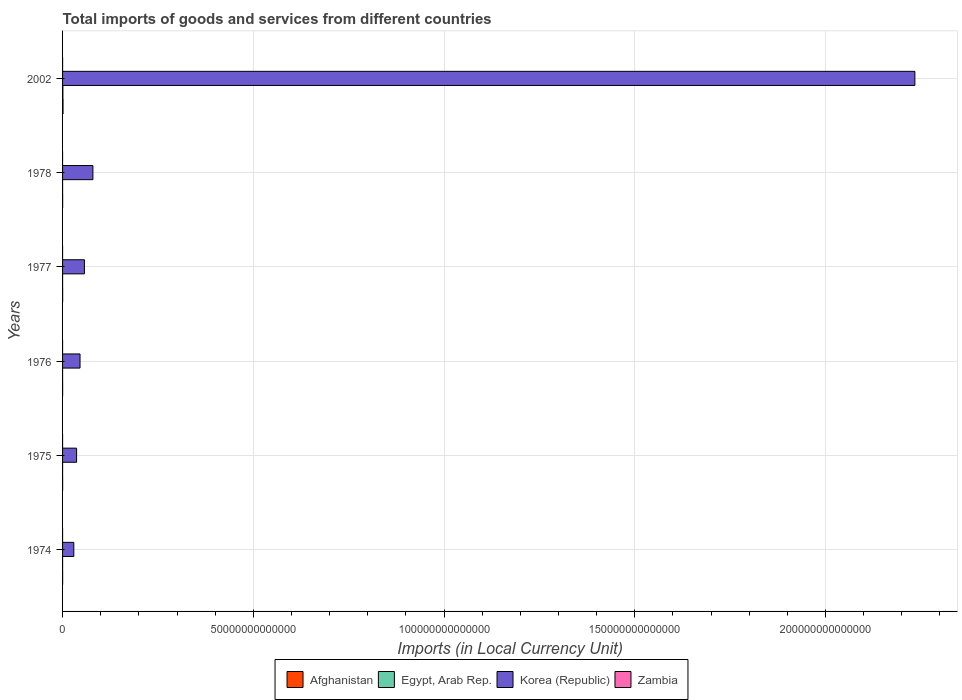How many different coloured bars are there?
Offer a terse response. 4. Are the number of bars per tick equal to the number of legend labels?
Provide a succinct answer. Yes. How many bars are there on the 6th tick from the bottom?
Offer a terse response. 4. What is the label of the 4th group of bars from the top?
Keep it short and to the point. 1976. In how many cases, is the number of bars for a given year not equal to the number of legend labels?
Your answer should be compact. 0. What is the Amount of goods and services imports in Zambia in 1978?
Offer a terse response. 8.31e+05. Across all years, what is the maximum Amount of goods and services imports in Egypt, Arab Rep.?
Provide a succinct answer. 8.59e+1. Across all years, what is the minimum Amount of goods and services imports in Zambia?
Keep it short and to the point. 7.39e+05. In which year was the Amount of goods and services imports in Afghanistan maximum?
Provide a short and direct response. 2002. In which year was the Amount of goods and services imports in Zambia minimum?
Make the answer very short. 1976. What is the total Amount of goods and services imports in Afghanistan in the graph?
Your answer should be compact. 2.08e+11. What is the difference between the Amount of goods and services imports in Korea (Republic) in 1974 and that in 1975?
Offer a terse response. -7.30e+11. What is the difference between the Amount of goods and services imports in Korea (Republic) in 1977 and the Amount of goods and services imports in Egypt, Arab Rep. in 1974?
Offer a very short reply. 5.73e+12. What is the average Amount of goods and services imports in Korea (Republic) per year?
Offer a very short reply. 4.14e+13. In the year 1975, what is the difference between the Amount of goods and services imports in Korea (Republic) and Amount of goods and services imports in Zambia?
Offer a very short reply. 3.68e+12. In how many years, is the Amount of goods and services imports in Zambia greater than 60000000000000 LCU?
Offer a terse response. 0. What is the ratio of the Amount of goods and services imports in Korea (Republic) in 1976 to that in 2002?
Make the answer very short. 0.02. Is the difference between the Amount of goods and services imports in Korea (Republic) in 1977 and 2002 greater than the difference between the Amount of goods and services imports in Zambia in 1977 and 2002?
Offer a very short reply. No. What is the difference between the highest and the second highest Amount of goods and services imports in Egypt, Arab Rep.?
Your answer should be very brief. 8.23e+1. What is the difference between the highest and the lowest Amount of goods and services imports in Egypt, Arab Rep.?
Keep it short and to the point. 8.43e+1. Is it the case that in every year, the sum of the Amount of goods and services imports in Egypt, Arab Rep. and Amount of goods and services imports in Korea (Republic) is greater than the sum of Amount of goods and services imports in Zambia and Amount of goods and services imports in Afghanistan?
Give a very brief answer. Yes. What does the 4th bar from the bottom in 1976 represents?
Give a very brief answer. Zambia. Is it the case that in every year, the sum of the Amount of goods and services imports in Korea (Republic) and Amount of goods and services imports in Egypt, Arab Rep. is greater than the Amount of goods and services imports in Zambia?
Keep it short and to the point. Yes. How many years are there in the graph?
Provide a succinct answer. 6. What is the difference between two consecutive major ticks on the X-axis?
Give a very brief answer. 5.00e+13. Are the values on the major ticks of X-axis written in scientific E-notation?
Provide a succinct answer. No. Where does the legend appear in the graph?
Give a very brief answer. Bottom center. What is the title of the graph?
Make the answer very short. Total imports of goods and services from different countries. What is the label or title of the X-axis?
Make the answer very short. Imports (in Local Currency Unit). What is the Imports (in Local Currency Unit) of Afghanistan in 1974?
Keep it short and to the point. 1.44e+1. What is the Imports (in Local Currency Unit) in Egypt, Arab Rep. in 1974?
Ensure brevity in your answer.  1.62e+09. What is the Imports (in Local Currency Unit) in Korea (Republic) in 1974?
Your answer should be very brief. 2.95e+12. What is the Imports (in Local Currency Unit) of Zambia in 1974?
Provide a short and direct response. 7.66e+05. What is the Imports (in Local Currency Unit) of Afghanistan in 1975?
Ensure brevity in your answer.  1.52e+1. What is the Imports (in Local Currency Unit) in Egypt, Arab Rep. in 1975?
Your answer should be very brief. 2.15e+09. What is the Imports (in Local Currency Unit) in Korea (Republic) in 1975?
Make the answer very short. 3.68e+12. What is the Imports (in Local Currency Unit) in Zambia in 1975?
Provide a short and direct response. 8.84e+05. What is the Imports (in Local Currency Unit) of Afghanistan in 1976?
Provide a succinct answer. 1.71e+1. What is the Imports (in Local Currency Unit) of Egypt, Arab Rep. in 1976?
Your answer should be compact. 2.29e+09. What is the Imports (in Local Currency Unit) in Korea (Republic) in 1976?
Provide a succinct answer. 4.58e+12. What is the Imports (in Local Currency Unit) in Zambia in 1976?
Provide a succinct answer. 7.39e+05. What is the Imports (in Local Currency Unit) of Afghanistan in 1977?
Keep it short and to the point. 1.97e+1. What is the Imports (in Local Currency Unit) of Egypt, Arab Rep. in 1977?
Provide a short and direct response. 2.77e+09. What is the Imports (in Local Currency Unit) in Korea (Republic) in 1977?
Make the answer very short. 5.73e+12. What is the Imports (in Local Currency Unit) of Zambia in 1977?
Keep it short and to the point. 8.33e+05. What is the Imports (in Local Currency Unit) of Afghanistan in 1978?
Your answer should be compact. 2.06e+1. What is the Imports (in Local Currency Unit) of Egypt, Arab Rep. in 1978?
Make the answer very short. 3.63e+09. What is the Imports (in Local Currency Unit) in Korea (Republic) in 1978?
Your answer should be compact. 7.96e+12. What is the Imports (in Local Currency Unit) of Zambia in 1978?
Your answer should be compact. 8.31e+05. What is the Imports (in Local Currency Unit) of Afghanistan in 2002?
Ensure brevity in your answer.  1.21e+11. What is the Imports (in Local Currency Unit) of Egypt, Arab Rep. in 2002?
Ensure brevity in your answer.  8.59e+1. What is the Imports (in Local Currency Unit) in Korea (Republic) in 2002?
Give a very brief answer. 2.23e+14. What is the Imports (in Local Currency Unit) in Zambia in 2002?
Ensure brevity in your answer.  6.97e+09. Across all years, what is the maximum Imports (in Local Currency Unit) of Afghanistan?
Provide a short and direct response. 1.21e+11. Across all years, what is the maximum Imports (in Local Currency Unit) in Egypt, Arab Rep.?
Give a very brief answer. 8.59e+1. Across all years, what is the maximum Imports (in Local Currency Unit) in Korea (Republic)?
Make the answer very short. 2.23e+14. Across all years, what is the maximum Imports (in Local Currency Unit) in Zambia?
Give a very brief answer. 6.97e+09. Across all years, what is the minimum Imports (in Local Currency Unit) of Afghanistan?
Offer a very short reply. 1.44e+1. Across all years, what is the minimum Imports (in Local Currency Unit) in Egypt, Arab Rep.?
Make the answer very short. 1.62e+09. Across all years, what is the minimum Imports (in Local Currency Unit) of Korea (Republic)?
Your answer should be very brief. 2.95e+12. Across all years, what is the minimum Imports (in Local Currency Unit) in Zambia?
Your answer should be very brief. 7.39e+05. What is the total Imports (in Local Currency Unit) in Afghanistan in the graph?
Give a very brief answer. 2.08e+11. What is the total Imports (in Local Currency Unit) of Egypt, Arab Rep. in the graph?
Your answer should be very brief. 9.84e+1. What is the total Imports (in Local Currency Unit) of Korea (Republic) in the graph?
Provide a succinct answer. 2.48e+14. What is the total Imports (in Local Currency Unit) of Zambia in the graph?
Provide a short and direct response. 6.97e+09. What is the difference between the Imports (in Local Currency Unit) in Afghanistan in 1974 and that in 1975?
Offer a very short reply. -8.00e+08. What is the difference between the Imports (in Local Currency Unit) of Egypt, Arab Rep. in 1974 and that in 1975?
Your response must be concise. -5.38e+08. What is the difference between the Imports (in Local Currency Unit) of Korea (Republic) in 1974 and that in 1975?
Give a very brief answer. -7.30e+11. What is the difference between the Imports (in Local Currency Unit) in Zambia in 1974 and that in 1975?
Provide a succinct answer. -1.18e+05. What is the difference between the Imports (in Local Currency Unit) of Afghanistan in 1974 and that in 1976?
Your response must be concise. -2.70e+09. What is the difference between the Imports (in Local Currency Unit) of Egypt, Arab Rep. in 1974 and that in 1976?
Offer a very short reply. -6.71e+08. What is the difference between the Imports (in Local Currency Unit) in Korea (Republic) in 1974 and that in 1976?
Ensure brevity in your answer.  -1.63e+12. What is the difference between the Imports (in Local Currency Unit) of Zambia in 1974 and that in 1976?
Make the answer very short. 2.65e+04. What is the difference between the Imports (in Local Currency Unit) in Afghanistan in 1974 and that in 1977?
Give a very brief answer. -5.30e+09. What is the difference between the Imports (in Local Currency Unit) of Egypt, Arab Rep. in 1974 and that in 1977?
Your answer should be very brief. -1.15e+09. What is the difference between the Imports (in Local Currency Unit) in Korea (Republic) in 1974 and that in 1977?
Offer a terse response. -2.78e+12. What is the difference between the Imports (in Local Currency Unit) of Zambia in 1974 and that in 1977?
Provide a short and direct response. -6.74e+04. What is the difference between the Imports (in Local Currency Unit) in Afghanistan in 1974 and that in 1978?
Your answer should be very brief. -6.20e+09. What is the difference between the Imports (in Local Currency Unit) of Egypt, Arab Rep. in 1974 and that in 1978?
Provide a short and direct response. -2.01e+09. What is the difference between the Imports (in Local Currency Unit) in Korea (Republic) in 1974 and that in 1978?
Offer a terse response. -5.01e+12. What is the difference between the Imports (in Local Currency Unit) of Zambia in 1974 and that in 1978?
Give a very brief answer. -6.54e+04. What is the difference between the Imports (in Local Currency Unit) in Afghanistan in 1974 and that in 2002?
Offer a terse response. -1.07e+11. What is the difference between the Imports (in Local Currency Unit) in Egypt, Arab Rep. in 1974 and that in 2002?
Make the answer very short. -8.43e+1. What is the difference between the Imports (in Local Currency Unit) in Korea (Republic) in 1974 and that in 2002?
Keep it short and to the point. -2.21e+14. What is the difference between the Imports (in Local Currency Unit) of Zambia in 1974 and that in 2002?
Give a very brief answer. -6.97e+09. What is the difference between the Imports (in Local Currency Unit) in Afghanistan in 1975 and that in 1976?
Keep it short and to the point. -1.90e+09. What is the difference between the Imports (in Local Currency Unit) in Egypt, Arab Rep. in 1975 and that in 1976?
Offer a terse response. -1.33e+08. What is the difference between the Imports (in Local Currency Unit) of Korea (Republic) in 1975 and that in 1976?
Provide a succinct answer. -9.01e+11. What is the difference between the Imports (in Local Currency Unit) in Zambia in 1975 and that in 1976?
Offer a terse response. 1.45e+05. What is the difference between the Imports (in Local Currency Unit) in Afghanistan in 1975 and that in 1977?
Provide a succinct answer. -4.50e+09. What is the difference between the Imports (in Local Currency Unit) in Egypt, Arab Rep. in 1975 and that in 1977?
Provide a succinct answer. -6.16e+08. What is the difference between the Imports (in Local Currency Unit) of Korea (Republic) in 1975 and that in 1977?
Offer a terse response. -2.05e+12. What is the difference between the Imports (in Local Currency Unit) of Zambia in 1975 and that in 1977?
Make the answer very short. 5.09e+04. What is the difference between the Imports (in Local Currency Unit) in Afghanistan in 1975 and that in 1978?
Make the answer very short. -5.40e+09. What is the difference between the Imports (in Local Currency Unit) in Egypt, Arab Rep. in 1975 and that in 1978?
Ensure brevity in your answer.  -1.47e+09. What is the difference between the Imports (in Local Currency Unit) in Korea (Republic) in 1975 and that in 1978?
Offer a terse response. -4.28e+12. What is the difference between the Imports (in Local Currency Unit) of Zambia in 1975 and that in 1978?
Offer a very short reply. 5.29e+04. What is the difference between the Imports (in Local Currency Unit) in Afghanistan in 1975 and that in 2002?
Your response must be concise. -1.06e+11. What is the difference between the Imports (in Local Currency Unit) of Egypt, Arab Rep. in 1975 and that in 2002?
Provide a short and direct response. -8.37e+1. What is the difference between the Imports (in Local Currency Unit) in Korea (Republic) in 1975 and that in 2002?
Your answer should be compact. -2.20e+14. What is the difference between the Imports (in Local Currency Unit) of Zambia in 1975 and that in 2002?
Your answer should be very brief. -6.97e+09. What is the difference between the Imports (in Local Currency Unit) in Afghanistan in 1976 and that in 1977?
Offer a very short reply. -2.60e+09. What is the difference between the Imports (in Local Currency Unit) of Egypt, Arab Rep. in 1976 and that in 1977?
Your answer should be very brief. -4.83e+08. What is the difference between the Imports (in Local Currency Unit) in Korea (Republic) in 1976 and that in 1977?
Your answer should be very brief. -1.15e+12. What is the difference between the Imports (in Local Currency Unit) in Zambia in 1976 and that in 1977?
Your answer should be very brief. -9.39e+04. What is the difference between the Imports (in Local Currency Unit) of Afghanistan in 1976 and that in 1978?
Provide a short and direct response. -3.50e+09. What is the difference between the Imports (in Local Currency Unit) in Egypt, Arab Rep. in 1976 and that in 1978?
Ensure brevity in your answer.  -1.34e+09. What is the difference between the Imports (in Local Currency Unit) of Korea (Republic) in 1976 and that in 1978?
Your answer should be very brief. -3.38e+12. What is the difference between the Imports (in Local Currency Unit) of Zambia in 1976 and that in 1978?
Offer a very short reply. -9.19e+04. What is the difference between the Imports (in Local Currency Unit) in Afghanistan in 1976 and that in 2002?
Provide a short and direct response. -1.04e+11. What is the difference between the Imports (in Local Currency Unit) in Egypt, Arab Rep. in 1976 and that in 2002?
Your answer should be compact. -8.36e+1. What is the difference between the Imports (in Local Currency Unit) of Korea (Republic) in 1976 and that in 2002?
Ensure brevity in your answer.  -2.19e+14. What is the difference between the Imports (in Local Currency Unit) of Zambia in 1976 and that in 2002?
Give a very brief answer. -6.97e+09. What is the difference between the Imports (in Local Currency Unit) of Afghanistan in 1977 and that in 1978?
Offer a terse response. -9.00e+08. What is the difference between the Imports (in Local Currency Unit) of Egypt, Arab Rep. in 1977 and that in 1978?
Give a very brief answer. -8.56e+08. What is the difference between the Imports (in Local Currency Unit) in Korea (Republic) in 1977 and that in 1978?
Make the answer very short. -2.23e+12. What is the difference between the Imports (in Local Currency Unit) of Zambia in 1977 and that in 1978?
Give a very brief answer. 2000. What is the difference between the Imports (in Local Currency Unit) in Afghanistan in 1977 and that in 2002?
Provide a short and direct response. -1.01e+11. What is the difference between the Imports (in Local Currency Unit) in Egypt, Arab Rep. in 1977 and that in 2002?
Offer a terse response. -8.31e+1. What is the difference between the Imports (in Local Currency Unit) in Korea (Republic) in 1977 and that in 2002?
Ensure brevity in your answer.  -2.18e+14. What is the difference between the Imports (in Local Currency Unit) in Zambia in 1977 and that in 2002?
Your answer should be very brief. -6.97e+09. What is the difference between the Imports (in Local Currency Unit) in Afghanistan in 1978 and that in 2002?
Make the answer very short. -1.00e+11. What is the difference between the Imports (in Local Currency Unit) in Egypt, Arab Rep. in 1978 and that in 2002?
Your answer should be compact. -8.23e+1. What is the difference between the Imports (in Local Currency Unit) in Korea (Republic) in 1978 and that in 2002?
Your answer should be very brief. -2.15e+14. What is the difference between the Imports (in Local Currency Unit) of Zambia in 1978 and that in 2002?
Provide a short and direct response. -6.97e+09. What is the difference between the Imports (in Local Currency Unit) in Afghanistan in 1974 and the Imports (in Local Currency Unit) in Egypt, Arab Rep. in 1975?
Provide a succinct answer. 1.22e+1. What is the difference between the Imports (in Local Currency Unit) in Afghanistan in 1974 and the Imports (in Local Currency Unit) in Korea (Republic) in 1975?
Your response must be concise. -3.66e+12. What is the difference between the Imports (in Local Currency Unit) in Afghanistan in 1974 and the Imports (in Local Currency Unit) in Zambia in 1975?
Your answer should be compact. 1.44e+1. What is the difference between the Imports (in Local Currency Unit) in Egypt, Arab Rep. in 1974 and the Imports (in Local Currency Unit) in Korea (Republic) in 1975?
Your answer should be very brief. -3.68e+12. What is the difference between the Imports (in Local Currency Unit) in Egypt, Arab Rep. in 1974 and the Imports (in Local Currency Unit) in Zambia in 1975?
Offer a terse response. 1.62e+09. What is the difference between the Imports (in Local Currency Unit) in Korea (Republic) in 1974 and the Imports (in Local Currency Unit) in Zambia in 1975?
Provide a succinct answer. 2.95e+12. What is the difference between the Imports (in Local Currency Unit) of Afghanistan in 1974 and the Imports (in Local Currency Unit) of Egypt, Arab Rep. in 1976?
Make the answer very short. 1.21e+1. What is the difference between the Imports (in Local Currency Unit) in Afghanistan in 1974 and the Imports (in Local Currency Unit) in Korea (Republic) in 1976?
Ensure brevity in your answer.  -4.56e+12. What is the difference between the Imports (in Local Currency Unit) in Afghanistan in 1974 and the Imports (in Local Currency Unit) in Zambia in 1976?
Provide a succinct answer. 1.44e+1. What is the difference between the Imports (in Local Currency Unit) of Egypt, Arab Rep. in 1974 and the Imports (in Local Currency Unit) of Korea (Republic) in 1976?
Your answer should be compact. -4.58e+12. What is the difference between the Imports (in Local Currency Unit) of Egypt, Arab Rep. in 1974 and the Imports (in Local Currency Unit) of Zambia in 1976?
Your response must be concise. 1.62e+09. What is the difference between the Imports (in Local Currency Unit) of Korea (Republic) in 1974 and the Imports (in Local Currency Unit) of Zambia in 1976?
Your answer should be compact. 2.95e+12. What is the difference between the Imports (in Local Currency Unit) in Afghanistan in 1974 and the Imports (in Local Currency Unit) in Egypt, Arab Rep. in 1977?
Keep it short and to the point. 1.16e+1. What is the difference between the Imports (in Local Currency Unit) of Afghanistan in 1974 and the Imports (in Local Currency Unit) of Korea (Republic) in 1977?
Give a very brief answer. -5.72e+12. What is the difference between the Imports (in Local Currency Unit) in Afghanistan in 1974 and the Imports (in Local Currency Unit) in Zambia in 1977?
Your answer should be compact. 1.44e+1. What is the difference between the Imports (in Local Currency Unit) of Egypt, Arab Rep. in 1974 and the Imports (in Local Currency Unit) of Korea (Republic) in 1977?
Give a very brief answer. -5.73e+12. What is the difference between the Imports (in Local Currency Unit) in Egypt, Arab Rep. in 1974 and the Imports (in Local Currency Unit) in Zambia in 1977?
Offer a very short reply. 1.62e+09. What is the difference between the Imports (in Local Currency Unit) in Korea (Republic) in 1974 and the Imports (in Local Currency Unit) in Zambia in 1977?
Make the answer very short. 2.95e+12. What is the difference between the Imports (in Local Currency Unit) of Afghanistan in 1974 and the Imports (in Local Currency Unit) of Egypt, Arab Rep. in 1978?
Ensure brevity in your answer.  1.08e+1. What is the difference between the Imports (in Local Currency Unit) of Afghanistan in 1974 and the Imports (in Local Currency Unit) of Korea (Republic) in 1978?
Provide a succinct answer. -7.94e+12. What is the difference between the Imports (in Local Currency Unit) in Afghanistan in 1974 and the Imports (in Local Currency Unit) in Zambia in 1978?
Offer a terse response. 1.44e+1. What is the difference between the Imports (in Local Currency Unit) in Egypt, Arab Rep. in 1974 and the Imports (in Local Currency Unit) in Korea (Republic) in 1978?
Give a very brief answer. -7.95e+12. What is the difference between the Imports (in Local Currency Unit) in Egypt, Arab Rep. in 1974 and the Imports (in Local Currency Unit) in Zambia in 1978?
Make the answer very short. 1.62e+09. What is the difference between the Imports (in Local Currency Unit) of Korea (Republic) in 1974 and the Imports (in Local Currency Unit) of Zambia in 1978?
Your answer should be compact. 2.95e+12. What is the difference between the Imports (in Local Currency Unit) of Afghanistan in 1974 and the Imports (in Local Currency Unit) of Egypt, Arab Rep. in 2002?
Give a very brief answer. -7.15e+1. What is the difference between the Imports (in Local Currency Unit) in Afghanistan in 1974 and the Imports (in Local Currency Unit) in Korea (Republic) in 2002?
Offer a very short reply. -2.23e+14. What is the difference between the Imports (in Local Currency Unit) in Afghanistan in 1974 and the Imports (in Local Currency Unit) in Zambia in 2002?
Ensure brevity in your answer.  7.43e+09. What is the difference between the Imports (in Local Currency Unit) of Egypt, Arab Rep. in 1974 and the Imports (in Local Currency Unit) of Korea (Republic) in 2002?
Make the answer very short. -2.23e+14. What is the difference between the Imports (in Local Currency Unit) in Egypt, Arab Rep. in 1974 and the Imports (in Local Currency Unit) in Zambia in 2002?
Offer a terse response. -5.35e+09. What is the difference between the Imports (in Local Currency Unit) in Korea (Republic) in 1974 and the Imports (in Local Currency Unit) in Zambia in 2002?
Make the answer very short. 2.94e+12. What is the difference between the Imports (in Local Currency Unit) in Afghanistan in 1975 and the Imports (in Local Currency Unit) in Egypt, Arab Rep. in 1976?
Your answer should be very brief. 1.29e+1. What is the difference between the Imports (in Local Currency Unit) of Afghanistan in 1975 and the Imports (in Local Currency Unit) of Korea (Republic) in 1976?
Offer a very short reply. -4.56e+12. What is the difference between the Imports (in Local Currency Unit) in Afghanistan in 1975 and the Imports (in Local Currency Unit) in Zambia in 1976?
Your response must be concise. 1.52e+1. What is the difference between the Imports (in Local Currency Unit) of Egypt, Arab Rep. in 1975 and the Imports (in Local Currency Unit) of Korea (Republic) in 1976?
Make the answer very short. -4.58e+12. What is the difference between the Imports (in Local Currency Unit) of Egypt, Arab Rep. in 1975 and the Imports (in Local Currency Unit) of Zambia in 1976?
Provide a succinct answer. 2.15e+09. What is the difference between the Imports (in Local Currency Unit) in Korea (Republic) in 1975 and the Imports (in Local Currency Unit) in Zambia in 1976?
Offer a terse response. 3.68e+12. What is the difference between the Imports (in Local Currency Unit) in Afghanistan in 1975 and the Imports (in Local Currency Unit) in Egypt, Arab Rep. in 1977?
Provide a succinct answer. 1.24e+1. What is the difference between the Imports (in Local Currency Unit) in Afghanistan in 1975 and the Imports (in Local Currency Unit) in Korea (Republic) in 1977?
Your answer should be very brief. -5.71e+12. What is the difference between the Imports (in Local Currency Unit) in Afghanistan in 1975 and the Imports (in Local Currency Unit) in Zambia in 1977?
Give a very brief answer. 1.52e+1. What is the difference between the Imports (in Local Currency Unit) in Egypt, Arab Rep. in 1975 and the Imports (in Local Currency Unit) in Korea (Republic) in 1977?
Give a very brief answer. -5.73e+12. What is the difference between the Imports (in Local Currency Unit) of Egypt, Arab Rep. in 1975 and the Imports (in Local Currency Unit) of Zambia in 1977?
Ensure brevity in your answer.  2.15e+09. What is the difference between the Imports (in Local Currency Unit) in Korea (Republic) in 1975 and the Imports (in Local Currency Unit) in Zambia in 1977?
Your response must be concise. 3.68e+12. What is the difference between the Imports (in Local Currency Unit) in Afghanistan in 1975 and the Imports (in Local Currency Unit) in Egypt, Arab Rep. in 1978?
Your response must be concise. 1.16e+1. What is the difference between the Imports (in Local Currency Unit) of Afghanistan in 1975 and the Imports (in Local Currency Unit) of Korea (Republic) in 1978?
Keep it short and to the point. -7.94e+12. What is the difference between the Imports (in Local Currency Unit) of Afghanistan in 1975 and the Imports (in Local Currency Unit) of Zambia in 1978?
Keep it short and to the point. 1.52e+1. What is the difference between the Imports (in Local Currency Unit) in Egypt, Arab Rep. in 1975 and the Imports (in Local Currency Unit) in Korea (Republic) in 1978?
Provide a succinct answer. -7.95e+12. What is the difference between the Imports (in Local Currency Unit) in Egypt, Arab Rep. in 1975 and the Imports (in Local Currency Unit) in Zambia in 1978?
Make the answer very short. 2.15e+09. What is the difference between the Imports (in Local Currency Unit) of Korea (Republic) in 1975 and the Imports (in Local Currency Unit) of Zambia in 1978?
Provide a succinct answer. 3.68e+12. What is the difference between the Imports (in Local Currency Unit) in Afghanistan in 1975 and the Imports (in Local Currency Unit) in Egypt, Arab Rep. in 2002?
Provide a short and direct response. -7.07e+1. What is the difference between the Imports (in Local Currency Unit) of Afghanistan in 1975 and the Imports (in Local Currency Unit) of Korea (Republic) in 2002?
Give a very brief answer. -2.23e+14. What is the difference between the Imports (in Local Currency Unit) in Afghanistan in 1975 and the Imports (in Local Currency Unit) in Zambia in 2002?
Make the answer very short. 8.23e+09. What is the difference between the Imports (in Local Currency Unit) in Egypt, Arab Rep. in 1975 and the Imports (in Local Currency Unit) in Korea (Republic) in 2002?
Your response must be concise. -2.23e+14. What is the difference between the Imports (in Local Currency Unit) in Egypt, Arab Rep. in 1975 and the Imports (in Local Currency Unit) in Zambia in 2002?
Offer a very short reply. -4.82e+09. What is the difference between the Imports (in Local Currency Unit) of Korea (Republic) in 1975 and the Imports (in Local Currency Unit) of Zambia in 2002?
Your answer should be very brief. 3.67e+12. What is the difference between the Imports (in Local Currency Unit) of Afghanistan in 1976 and the Imports (in Local Currency Unit) of Egypt, Arab Rep. in 1977?
Your answer should be compact. 1.43e+1. What is the difference between the Imports (in Local Currency Unit) in Afghanistan in 1976 and the Imports (in Local Currency Unit) in Korea (Republic) in 1977?
Keep it short and to the point. -5.71e+12. What is the difference between the Imports (in Local Currency Unit) in Afghanistan in 1976 and the Imports (in Local Currency Unit) in Zambia in 1977?
Provide a short and direct response. 1.71e+1. What is the difference between the Imports (in Local Currency Unit) of Egypt, Arab Rep. in 1976 and the Imports (in Local Currency Unit) of Korea (Republic) in 1977?
Offer a terse response. -5.73e+12. What is the difference between the Imports (in Local Currency Unit) of Egypt, Arab Rep. in 1976 and the Imports (in Local Currency Unit) of Zambia in 1977?
Ensure brevity in your answer.  2.29e+09. What is the difference between the Imports (in Local Currency Unit) of Korea (Republic) in 1976 and the Imports (in Local Currency Unit) of Zambia in 1977?
Offer a very short reply. 4.58e+12. What is the difference between the Imports (in Local Currency Unit) of Afghanistan in 1976 and the Imports (in Local Currency Unit) of Egypt, Arab Rep. in 1978?
Offer a very short reply. 1.35e+1. What is the difference between the Imports (in Local Currency Unit) of Afghanistan in 1976 and the Imports (in Local Currency Unit) of Korea (Republic) in 1978?
Offer a terse response. -7.94e+12. What is the difference between the Imports (in Local Currency Unit) in Afghanistan in 1976 and the Imports (in Local Currency Unit) in Zambia in 1978?
Provide a succinct answer. 1.71e+1. What is the difference between the Imports (in Local Currency Unit) in Egypt, Arab Rep. in 1976 and the Imports (in Local Currency Unit) in Korea (Republic) in 1978?
Make the answer very short. -7.95e+12. What is the difference between the Imports (in Local Currency Unit) of Egypt, Arab Rep. in 1976 and the Imports (in Local Currency Unit) of Zambia in 1978?
Your answer should be compact. 2.29e+09. What is the difference between the Imports (in Local Currency Unit) in Korea (Republic) in 1976 and the Imports (in Local Currency Unit) in Zambia in 1978?
Offer a very short reply. 4.58e+12. What is the difference between the Imports (in Local Currency Unit) of Afghanistan in 1976 and the Imports (in Local Currency Unit) of Egypt, Arab Rep. in 2002?
Your response must be concise. -6.88e+1. What is the difference between the Imports (in Local Currency Unit) in Afghanistan in 1976 and the Imports (in Local Currency Unit) in Korea (Republic) in 2002?
Keep it short and to the point. -2.23e+14. What is the difference between the Imports (in Local Currency Unit) in Afghanistan in 1976 and the Imports (in Local Currency Unit) in Zambia in 2002?
Offer a terse response. 1.01e+1. What is the difference between the Imports (in Local Currency Unit) of Egypt, Arab Rep. in 1976 and the Imports (in Local Currency Unit) of Korea (Republic) in 2002?
Offer a very short reply. -2.23e+14. What is the difference between the Imports (in Local Currency Unit) in Egypt, Arab Rep. in 1976 and the Imports (in Local Currency Unit) in Zambia in 2002?
Your answer should be very brief. -4.68e+09. What is the difference between the Imports (in Local Currency Unit) in Korea (Republic) in 1976 and the Imports (in Local Currency Unit) in Zambia in 2002?
Keep it short and to the point. 4.57e+12. What is the difference between the Imports (in Local Currency Unit) in Afghanistan in 1977 and the Imports (in Local Currency Unit) in Egypt, Arab Rep. in 1978?
Keep it short and to the point. 1.61e+1. What is the difference between the Imports (in Local Currency Unit) of Afghanistan in 1977 and the Imports (in Local Currency Unit) of Korea (Republic) in 1978?
Offer a very short reply. -7.94e+12. What is the difference between the Imports (in Local Currency Unit) of Afghanistan in 1977 and the Imports (in Local Currency Unit) of Zambia in 1978?
Offer a terse response. 1.97e+1. What is the difference between the Imports (in Local Currency Unit) of Egypt, Arab Rep. in 1977 and the Imports (in Local Currency Unit) of Korea (Republic) in 1978?
Offer a terse response. -7.95e+12. What is the difference between the Imports (in Local Currency Unit) of Egypt, Arab Rep. in 1977 and the Imports (in Local Currency Unit) of Zambia in 1978?
Provide a short and direct response. 2.77e+09. What is the difference between the Imports (in Local Currency Unit) in Korea (Republic) in 1977 and the Imports (in Local Currency Unit) in Zambia in 1978?
Make the answer very short. 5.73e+12. What is the difference between the Imports (in Local Currency Unit) of Afghanistan in 1977 and the Imports (in Local Currency Unit) of Egypt, Arab Rep. in 2002?
Give a very brief answer. -6.62e+1. What is the difference between the Imports (in Local Currency Unit) of Afghanistan in 1977 and the Imports (in Local Currency Unit) of Korea (Republic) in 2002?
Give a very brief answer. -2.23e+14. What is the difference between the Imports (in Local Currency Unit) of Afghanistan in 1977 and the Imports (in Local Currency Unit) of Zambia in 2002?
Provide a succinct answer. 1.27e+1. What is the difference between the Imports (in Local Currency Unit) in Egypt, Arab Rep. in 1977 and the Imports (in Local Currency Unit) in Korea (Republic) in 2002?
Offer a very short reply. -2.23e+14. What is the difference between the Imports (in Local Currency Unit) in Egypt, Arab Rep. in 1977 and the Imports (in Local Currency Unit) in Zambia in 2002?
Keep it short and to the point. -4.20e+09. What is the difference between the Imports (in Local Currency Unit) in Korea (Republic) in 1977 and the Imports (in Local Currency Unit) in Zambia in 2002?
Offer a terse response. 5.72e+12. What is the difference between the Imports (in Local Currency Unit) of Afghanistan in 1978 and the Imports (in Local Currency Unit) of Egypt, Arab Rep. in 2002?
Ensure brevity in your answer.  -6.53e+1. What is the difference between the Imports (in Local Currency Unit) in Afghanistan in 1978 and the Imports (in Local Currency Unit) in Korea (Republic) in 2002?
Give a very brief answer. -2.23e+14. What is the difference between the Imports (in Local Currency Unit) of Afghanistan in 1978 and the Imports (in Local Currency Unit) of Zambia in 2002?
Provide a short and direct response. 1.36e+1. What is the difference between the Imports (in Local Currency Unit) in Egypt, Arab Rep. in 1978 and the Imports (in Local Currency Unit) in Korea (Republic) in 2002?
Keep it short and to the point. -2.23e+14. What is the difference between the Imports (in Local Currency Unit) in Egypt, Arab Rep. in 1978 and the Imports (in Local Currency Unit) in Zambia in 2002?
Provide a short and direct response. -3.34e+09. What is the difference between the Imports (in Local Currency Unit) in Korea (Republic) in 1978 and the Imports (in Local Currency Unit) in Zambia in 2002?
Your answer should be compact. 7.95e+12. What is the average Imports (in Local Currency Unit) of Afghanistan per year?
Offer a very short reply. 3.47e+1. What is the average Imports (in Local Currency Unit) in Egypt, Arab Rep. per year?
Give a very brief answer. 1.64e+1. What is the average Imports (in Local Currency Unit) of Korea (Republic) per year?
Offer a very short reply. 4.14e+13. What is the average Imports (in Local Currency Unit) in Zambia per year?
Ensure brevity in your answer.  1.16e+09. In the year 1974, what is the difference between the Imports (in Local Currency Unit) in Afghanistan and Imports (in Local Currency Unit) in Egypt, Arab Rep.?
Give a very brief answer. 1.28e+1. In the year 1974, what is the difference between the Imports (in Local Currency Unit) in Afghanistan and Imports (in Local Currency Unit) in Korea (Republic)?
Provide a short and direct response. -2.93e+12. In the year 1974, what is the difference between the Imports (in Local Currency Unit) in Afghanistan and Imports (in Local Currency Unit) in Zambia?
Keep it short and to the point. 1.44e+1. In the year 1974, what is the difference between the Imports (in Local Currency Unit) in Egypt, Arab Rep. and Imports (in Local Currency Unit) in Korea (Republic)?
Give a very brief answer. -2.95e+12. In the year 1974, what is the difference between the Imports (in Local Currency Unit) in Egypt, Arab Rep. and Imports (in Local Currency Unit) in Zambia?
Ensure brevity in your answer.  1.62e+09. In the year 1974, what is the difference between the Imports (in Local Currency Unit) in Korea (Republic) and Imports (in Local Currency Unit) in Zambia?
Ensure brevity in your answer.  2.95e+12. In the year 1975, what is the difference between the Imports (in Local Currency Unit) of Afghanistan and Imports (in Local Currency Unit) of Egypt, Arab Rep.?
Your answer should be compact. 1.30e+1. In the year 1975, what is the difference between the Imports (in Local Currency Unit) of Afghanistan and Imports (in Local Currency Unit) of Korea (Republic)?
Offer a very short reply. -3.66e+12. In the year 1975, what is the difference between the Imports (in Local Currency Unit) in Afghanistan and Imports (in Local Currency Unit) in Zambia?
Offer a very short reply. 1.52e+1. In the year 1975, what is the difference between the Imports (in Local Currency Unit) of Egypt, Arab Rep. and Imports (in Local Currency Unit) of Korea (Republic)?
Keep it short and to the point. -3.68e+12. In the year 1975, what is the difference between the Imports (in Local Currency Unit) in Egypt, Arab Rep. and Imports (in Local Currency Unit) in Zambia?
Give a very brief answer. 2.15e+09. In the year 1975, what is the difference between the Imports (in Local Currency Unit) of Korea (Republic) and Imports (in Local Currency Unit) of Zambia?
Offer a very short reply. 3.68e+12. In the year 1976, what is the difference between the Imports (in Local Currency Unit) in Afghanistan and Imports (in Local Currency Unit) in Egypt, Arab Rep.?
Your response must be concise. 1.48e+1. In the year 1976, what is the difference between the Imports (in Local Currency Unit) of Afghanistan and Imports (in Local Currency Unit) of Korea (Republic)?
Your answer should be very brief. -4.56e+12. In the year 1976, what is the difference between the Imports (in Local Currency Unit) in Afghanistan and Imports (in Local Currency Unit) in Zambia?
Give a very brief answer. 1.71e+1. In the year 1976, what is the difference between the Imports (in Local Currency Unit) of Egypt, Arab Rep. and Imports (in Local Currency Unit) of Korea (Republic)?
Offer a very short reply. -4.58e+12. In the year 1976, what is the difference between the Imports (in Local Currency Unit) in Egypt, Arab Rep. and Imports (in Local Currency Unit) in Zambia?
Ensure brevity in your answer.  2.29e+09. In the year 1976, what is the difference between the Imports (in Local Currency Unit) of Korea (Republic) and Imports (in Local Currency Unit) of Zambia?
Make the answer very short. 4.58e+12. In the year 1977, what is the difference between the Imports (in Local Currency Unit) of Afghanistan and Imports (in Local Currency Unit) of Egypt, Arab Rep.?
Offer a very short reply. 1.69e+1. In the year 1977, what is the difference between the Imports (in Local Currency Unit) in Afghanistan and Imports (in Local Currency Unit) in Korea (Republic)?
Your answer should be compact. -5.71e+12. In the year 1977, what is the difference between the Imports (in Local Currency Unit) of Afghanistan and Imports (in Local Currency Unit) of Zambia?
Offer a terse response. 1.97e+1. In the year 1977, what is the difference between the Imports (in Local Currency Unit) in Egypt, Arab Rep. and Imports (in Local Currency Unit) in Korea (Republic)?
Offer a terse response. -5.73e+12. In the year 1977, what is the difference between the Imports (in Local Currency Unit) of Egypt, Arab Rep. and Imports (in Local Currency Unit) of Zambia?
Offer a terse response. 2.77e+09. In the year 1977, what is the difference between the Imports (in Local Currency Unit) in Korea (Republic) and Imports (in Local Currency Unit) in Zambia?
Your answer should be very brief. 5.73e+12. In the year 1978, what is the difference between the Imports (in Local Currency Unit) in Afghanistan and Imports (in Local Currency Unit) in Egypt, Arab Rep.?
Provide a succinct answer. 1.70e+1. In the year 1978, what is the difference between the Imports (in Local Currency Unit) of Afghanistan and Imports (in Local Currency Unit) of Korea (Republic)?
Your response must be concise. -7.94e+12. In the year 1978, what is the difference between the Imports (in Local Currency Unit) of Afghanistan and Imports (in Local Currency Unit) of Zambia?
Make the answer very short. 2.06e+1. In the year 1978, what is the difference between the Imports (in Local Currency Unit) in Egypt, Arab Rep. and Imports (in Local Currency Unit) in Korea (Republic)?
Your answer should be very brief. -7.95e+12. In the year 1978, what is the difference between the Imports (in Local Currency Unit) of Egypt, Arab Rep. and Imports (in Local Currency Unit) of Zambia?
Keep it short and to the point. 3.63e+09. In the year 1978, what is the difference between the Imports (in Local Currency Unit) of Korea (Republic) and Imports (in Local Currency Unit) of Zambia?
Your answer should be compact. 7.96e+12. In the year 2002, what is the difference between the Imports (in Local Currency Unit) in Afghanistan and Imports (in Local Currency Unit) in Egypt, Arab Rep.?
Provide a succinct answer. 3.52e+1. In the year 2002, what is the difference between the Imports (in Local Currency Unit) of Afghanistan and Imports (in Local Currency Unit) of Korea (Republic)?
Offer a terse response. -2.23e+14. In the year 2002, what is the difference between the Imports (in Local Currency Unit) in Afghanistan and Imports (in Local Currency Unit) in Zambia?
Your answer should be compact. 1.14e+11. In the year 2002, what is the difference between the Imports (in Local Currency Unit) in Egypt, Arab Rep. and Imports (in Local Currency Unit) in Korea (Republic)?
Ensure brevity in your answer.  -2.23e+14. In the year 2002, what is the difference between the Imports (in Local Currency Unit) of Egypt, Arab Rep. and Imports (in Local Currency Unit) of Zambia?
Offer a terse response. 7.89e+1. In the year 2002, what is the difference between the Imports (in Local Currency Unit) in Korea (Republic) and Imports (in Local Currency Unit) in Zambia?
Your answer should be compact. 2.23e+14. What is the ratio of the Imports (in Local Currency Unit) of Egypt, Arab Rep. in 1974 to that in 1975?
Offer a terse response. 0.75. What is the ratio of the Imports (in Local Currency Unit) of Korea (Republic) in 1974 to that in 1975?
Offer a terse response. 0.8. What is the ratio of the Imports (in Local Currency Unit) in Zambia in 1974 to that in 1975?
Ensure brevity in your answer.  0.87. What is the ratio of the Imports (in Local Currency Unit) of Afghanistan in 1974 to that in 1976?
Make the answer very short. 0.84. What is the ratio of the Imports (in Local Currency Unit) in Egypt, Arab Rep. in 1974 to that in 1976?
Provide a short and direct response. 0.71. What is the ratio of the Imports (in Local Currency Unit) in Korea (Republic) in 1974 to that in 1976?
Offer a terse response. 0.64. What is the ratio of the Imports (in Local Currency Unit) of Zambia in 1974 to that in 1976?
Offer a very short reply. 1.04. What is the ratio of the Imports (in Local Currency Unit) in Afghanistan in 1974 to that in 1977?
Offer a terse response. 0.73. What is the ratio of the Imports (in Local Currency Unit) of Egypt, Arab Rep. in 1974 to that in 1977?
Your answer should be compact. 0.58. What is the ratio of the Imports (in Local Currency Unit) of Korea (Republic) in 1974 to that in 1977?
Your answer should be very brief. 0.51. What is the ratio of the Imports (in Local Currency Unit) in Zambia in 1974 to that in 1977?
Provide a succinct answer. 0.92. What is the ratio of the Imports (in Local Currency Unit) of Afghanistan in 1974 to that in 1978?
Provide a succinct answer. 0.7. What is the ratio of the Imports (in Local Currency Unit) of Egypt, Arab Rep. in 1974 to that in 1978?
Provide a succinct answer. 0.45. What is the ratio of the Imports (in Local Currency Unit) of Korea (Republic) in 1974 to that in 1978?
Keep it short and to the point. 0.37. What is the ratio of the Imports (in Local Currency Unit) in Zambia in 1974 to that in 1978?
Give a very brief answer. 0.92. What is the ratio of the Imports (in Local Currency Unit) in Afghanistan in 1974 to that in 2002?
Provide a short and direct response. 0.12. What is the ratio of the Imports (in Local Currency Unit) in Egypt, Arab Rep. in 1974 to that in 2002?
Give a very brief answer. 0.02. What is the ratio of the Imports (in Local Currency Unit) in Korea (Republic) in 1974 to that in 2002?
Provide a succinct answer. 0.01. What is the ratio of the Imports (in Local Currency Unit) in Zambia in 1974 to that in 2002?
Offer a very short reply. 0. What is the ratio of the Imports (in Local Currency Unit) of Afghanistan in 1975 to that in 1976?
Provide a succinct answer. 0.89. What is the ratio of the Imports (in Local Currency Unit) of Egypt, Arab Rep. in 1975 to that in 1976?
Provide a short and direct response. 0.94. What is the ratio of the Imports (in Local Currency Unit) in Korea (Republic) in 1975 to that in 1976?
Provide a short and direct response. 0.8. What is the ratio of the Imports (in Local Currency Unit) in Zambia in 1975 to that in 1976?
Provide a short and direct response. 1.2. What is the ratio of the Imports (in Local Currency Unit) of Afghanistan in 1975 to that in 1977?
Your answer should be compact. 0.77. What is the ratio of the Imports (in Local Currency Unit) in Egypt, Arab Rep. in 1975 to that in 1977?
Keep it short and to the point. 0.78. What is the ratio of the Imports (in Local Currency Unit) of Korea (Republic) in 1975 to that in 1977?
Your response must be concise. 0.64. What is the ratio of the Imports (in Local Currency Unit) of Zambia in 1975 to that in 1977?
Make the answer very short. 1.06. What is the ratio of the Imports (in Local Currency Unit) in Afghanistan in 1975 to that in 1978?
Offer a very short reply. 0.74. What is the ratio of the Imports (in Local Currency Unit) of Egypt, Arab Rep. in 1975 to that in 1978?
Your answer should be compact. 0.59. What is the ratio of the Imports (in Local Currency Unit) in Korea (Republic) in 1975 to that in 1978?
Make the answer very short. 0.46. What is the ratio of the Imports (in Local Currency Unit) of Zambia in 1975 to that in 1978?
Your answer should be very brief. 1.06. What is the ratio of the Imports (in Local Currency Unit) of Afghanistan in 1975 to that in 2002?
Offer a very short reply. 0.13. What is the ratio of the Imports (in Local Currency Unit) in Egypt, Arab Rep. in 1975 to that in 2002?
Your answer should be very brief. 0.03. What is the ratio of the Imports (in Local Currency Unit) of Korea (Republic) in 1975 to that in 2002?
Your answer should be very brief. 0.02. What is the ratio of the Imports (in Local Currency Unit) in Zambia in 1975 to that in 2002?
Your response must be concise. 0. What is the ratio of the Imports (in Local Currency Unit) of Afghanistan in 1976 to that in 1977?
Offer a terse response. 0.87. What is the ratio of the Imports (in Local Currency Unit) of Egypt, Arab Rep. in 1976 to that in 1977?
Make the answer very short. 0.83. What is the ratio of the Imports (in Local Currency Unit) of Korea (Republic) in 1976 to that in 1977?
Ensure brevity in your answer.  0.8. What is the ratio of the Imports (in Local Currency Unit) of Zambia in 1976 to that in 1977?
Ensure brevity in your answer.  0.89. What is the ratio of the Imports (in Local Currency Unit) in Afghanistan in 1976 to that in 1978?
Offer a terse response. 0.83. What is the ratio of the Imports (in Local Currency Unit) of Egypt, Arab Rep. in 1976 to that in 1978?
Your answer should be very brief. 0.63. What is the ratio of the Imports (in Local Currency Unit) in Korea (Republic) in 1976 to that in 1978?
Make the answer very short. 0.58. What is the ratio of the Imports (in Local Currency Unit) of Zambia in 1976 to that in 1978?
Provide a short and direct response. 0.89. What is the ratio of the Imports (in Local Currency Unit) in Afghanistan in 1976 to that in 2002?
Your answer should be compact. 0.14. What is the ratio of the Imports (in Local Currency Unit) in Egypt, Arab Rep. in 1976 to that in 2002?
Your answer should be very brief. 0.03. What is the ratio of the Imports (in Local Currency Unit) of Korea (Republic) in 1976 to that in 2002?
Provide a short and direct response. 0.02. What is the ratio of the Imports (in Local Currency Unit) of Zambia in 1976 to that in 2002?
Your answer should be compact. 0. What is the ratio of the Imports (in Local Currency Unit) in Afghanistan in 1977 to that in 1978?
Your answer should be very brief. 0.96. What is the ratio of the Imports (in Local Currency Unit) in Egypt, Arab Rep. in 1977 to that in 1978?
Keep it short and to the point. 0.76. What is the ratio of the Imports (in Local Currency Unit) of Korea (Republic) in 1977 to that in 1978?
Your answer should be very brief. 0.72. What is the ratio of the Imports (in Local Currency Unit) of Afghanistan in 1977 to that in 2002?
Your response must be concise. 0.16. What is the ratio of the Imports (in Local Currency Unit) of Egypt, Arab Rep. in 1977 to that in 2002?
Give a very brief answer. 0.03. What is the ratio of the Imports (in Local Currency Unit) of Korea (Republic) in 1977 to that in 2002?
Your answer should be very brief. 0.03. What is the ratio of the Imports (in Local Currency Unit) in Zambia in 1977 to that in 2002?
Give a very brief answer. 0. What is the ratio of the Imports (in Local Currency Unit) of Afghanistan in 1978 to that in 2002?
Your answer should be compact. 0.17. What is the ratio of the Imports (in Local Currency Unit) of Egypt, Arab Rep. in 1978 to that in 2002?
Your response must be concise. 0.04. What is the ratio of the Imports (in Local Currency Unit) of Korea (Republic) in 1978 to that in 2002?
Give a very brief answer. 0.04. What is the difference between the highest and the second highest Imports (in Local Currency Unit) of Afghanistan?
Offer a very short reply. 1.00e+11. What is the difference between the highest and the second highest Imports (in Local Currency Unit) in Egypt, Arab Rep.?
Make the answer very short. 8.23e+1. What is the difference between the highest and the second highest Imports (in Local Currency Unit) in Korea (Republic)?
Offer a very short reply. 2.15e+14. What is the difference between the highest and the second highest Imports (in Local Currency Unit) of Zambia?
Your response must be concise. 6.97e+09. What is the difference between the highest and the lowest Imports (in Local Currency Unit) of Afghanistan?
Make the answer very short. 1.07e+11. What is the difference between the highest and the lowest Imports (in Local Currency Unit) of Egypt, Arab Rep.?
Your answer should be compact. 8.43e+1. What is the difference between the highest and the lowest Imports (in Local Currency Unit) of Korea (Republic)?
Keep it short and to the point. 2.21e+14. What is the difference between the highest and the lowest Imports (in Local Currency Unit) in Zambia?
Provide a short and direct response. 6.97e+09. 